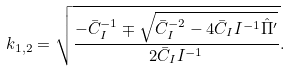<formula> <loc_0><loc_0><loc_500><loc_500>k _ { 1 , 2 } = \sqrt { \frac { - \bar { C } _ { I } ^ { - 1 } \mp \sqrt { \bar { C } _ { I } ^ { - 2 } - 4 \bar { C } _ { I } I ^ { - 1 } \hat { \Pi } ^ { \prime } } } { 2 \bar { C } _ { I } I ^ { - 1 } } } .</formula> 